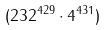<formula> <loc_0><loc_0><loc_500><loc_500>( 2 3 2 ^ { 4 2 9 } \cdot 4 ^ { 4 3 1 } )</formula> 